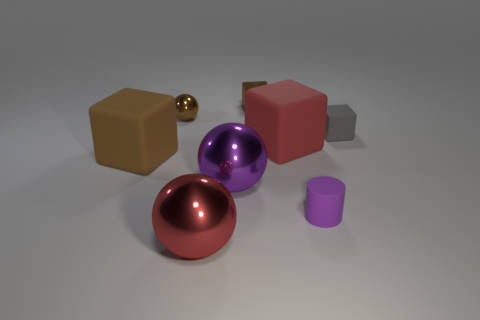There is a small metal sphere; is its color the same as the big shiny ball that is in front of the small purple matte object?
Offer a terse response. No. Is there any other thing that has the same material as the red ball?
Give a very brief answer. Yes. What shape is the big purple object?
Offer a terse response. Sphere. There is a sphere in front of the big purple metal object that is left of the shiny block; what is its size?
Give a very brief answer. Large. Is the number of red rubber objects in front of the tiny metallic ball the same as the number of matte cylinders that are in front of the tiny purple object?
Provide a succinct answer. No. There is a block that is to the left of the red matte cube and behind the large red cube; what is it made of?
Keep it short and to the point. Metal. There is a gray matte object; does it have the same size as the brown block that is to the right of the large brown rubber block?
Make the answer very short. Yes. What number of other things are there of the same color as the tiny ball?
Offer a terse response. 2. Are there more brown objects that are in front of the big red matte block than red metal things?
Offer a very short reply. No. What color is the large cube to the right of the large brown rubber thing that is left of the sphere behind the gray matte object?
Provide a short and direct response. Red. 